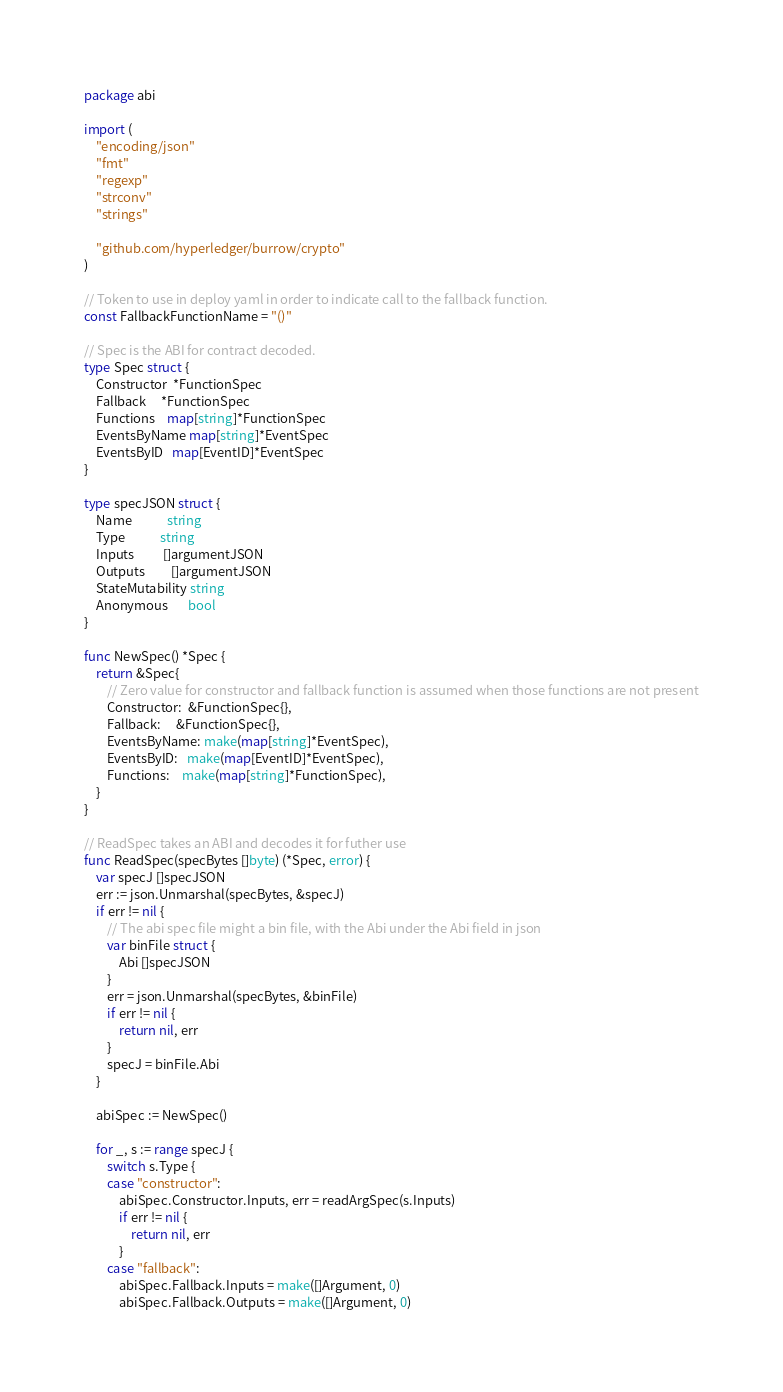Convert code to text. <code><loc_0><loc_0><loc_500><loc_500><_Go_>package abi

import (
	"encoding/json"
	"fmt"
	"regexp"
	"strconv"
	"strings"

	"github.com/hyperledger/burrow/crypto"
)

// Token to use in deploy yaml in order to indicate call to the fallback function.
const FallbackFunctionName = "()"

// Spec is the ABI for contract decoded.
type Spec struct {
	Constructor  *FunctionSpec
	Fallback     *FunctionSpec
	Functions    map[string]*FunctionSpec
	EventsByName map[string]*EventSpec
	EventsByID   map[EventID]*EventSpec
}

type specJSON struct {
	Name            string
	Type            string
	Inputs          []argumentJSON
	Outputs         []argumentJSON
	StateMutability string
	Anonymous       bool
}

func NewSpec() *Spec {
	return &Spec{
		// Zero value for constructor and fallback function is assumed when those functions are not present
		Constructor:  &FunctionSpec{},
		Fallback:     &FunctionSpec{},
		EventsByName: make(map[string]*EventSpec),
		EventsByID:   make(map[EventID]*EventSpec),
		Functions:    make(map[string]*FunctionSpec),
	}
}

// ReadSpec takes an ABI and decodes it for futher use
func ReadSpec(specBytes []byte) (*Spec, error) {
	var specJ []specJSON
	err := json.Unmarshal(specBytes, &specJ)
	if err != nil {
		// The abi spec file might a bin file, with the Abi under the Abi field in json
		var binFile struct {
			Abi []specJSON
		}
		err = json.Unmarshal(specBytes, &binFile)
		if err != nil {
			return nil, err
		}
		specJ = binFile.Abi
	}

	abiSpec := NewSpec()

	for _, s := range specJ {
		switch s.Type {
		case "constructor":
			abiSpec.Constructor.Inputs, err = readArgSpec(s.Inputs)
			if err != nil {
				return nil, err
			}
		case "fallback":
			abiSpec.Fallback.Inputs = make([]Argument, 0)
			abiSpec.Fallback.Outputs = make([]Argument, 0)</code> 